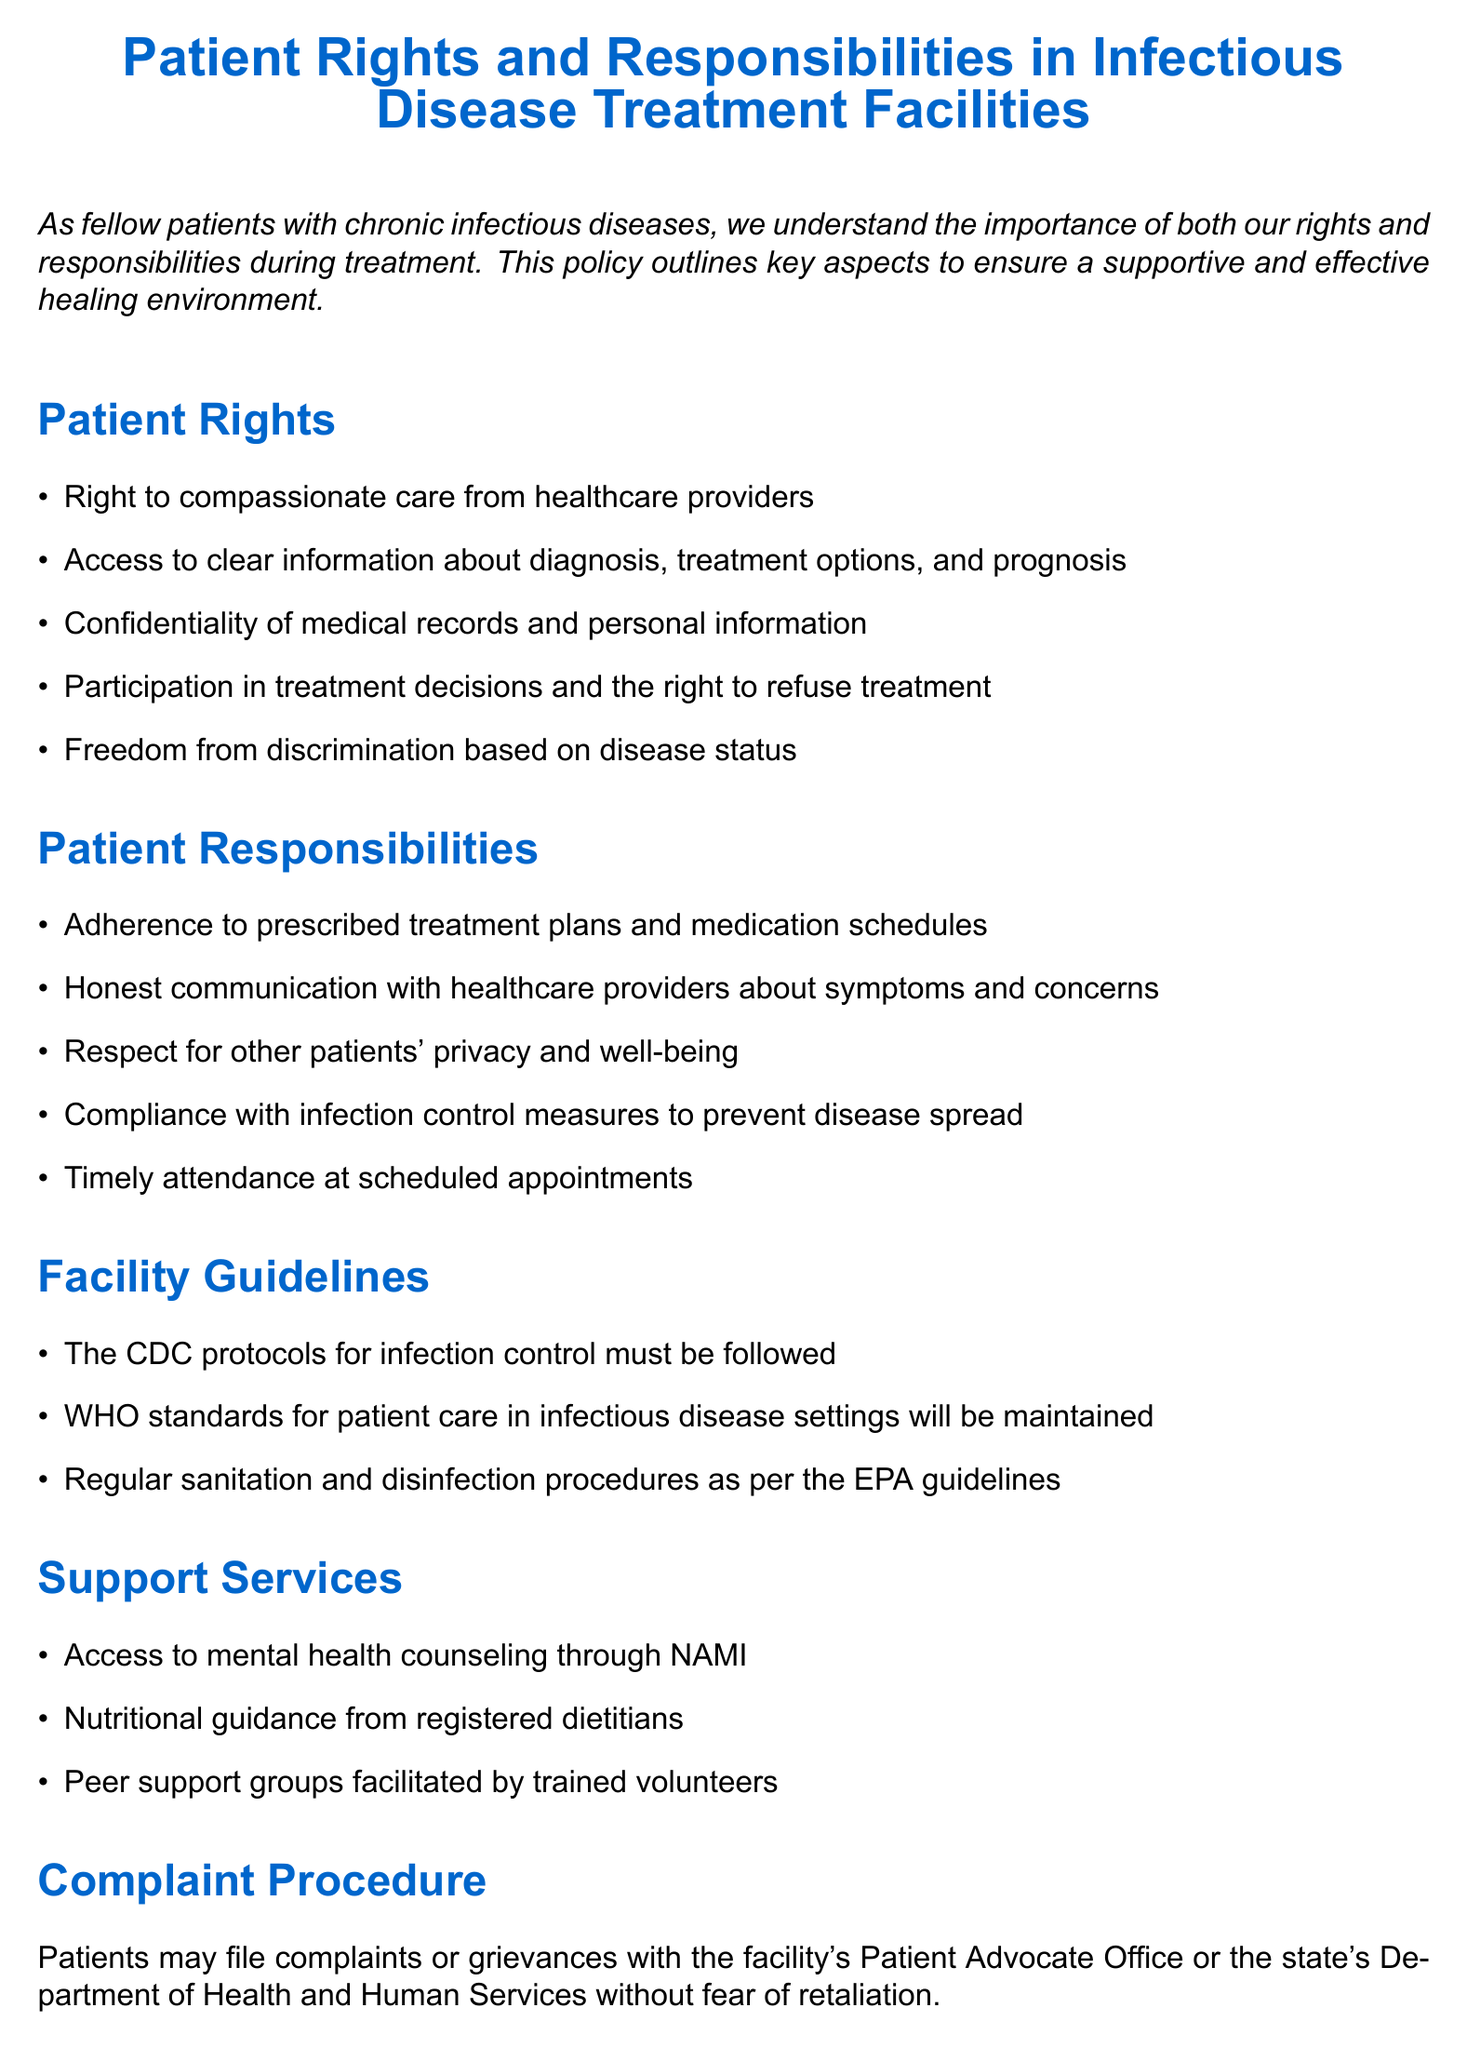What is the right of patients regarding care? Patients have the right to compassionate care from healthcare providers.
Answer: Compassionate care What must patients adhere to during treatment? Patients are responsible for adherence to prescribed treatment plans and medication schedules.
Answer: Treatment plans What should patients do if they have a grievance? Patients may file complaints or grievances with the facility's Patient Advocate Office or the state's Department of Health and Human Services.
Answer: Patient Advocate Office What standards are mentioned for patient care in the facility? The facility maintains WHO standards for patient care in infectious disease settings.
Answer: WHO standards What type of counseling is available as a support service? Access to mental health counseling through NAMI is provided as a support service.
Answer: Mental health counseling What does the emergency protocol require patients to do? In case of a medical emergency, patients should immediately alert staff or use the call button.
Answer: Alert staff How often must regular sanitation procedures be followed? Regular sanitation and disinfection procedures must be followed as per the EPA guidelines.
Answer: EPA guidelines What is the consequence of filing a complaint? Patients can file complaints without fear of retaliation.
Answer: Without fear of retaliation What is required from patients regarding infection control? Patients are responsible for compliance with infection control measures to prevent disease spread.
Answer: Infection control measures 